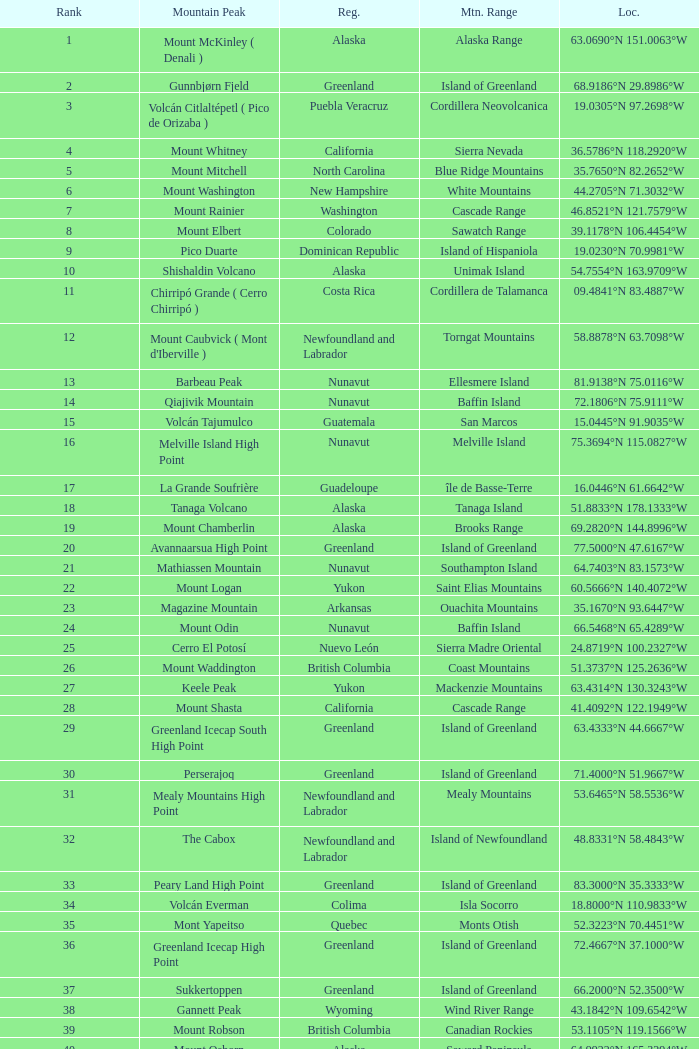Name the Mountain Peak which has a Rank of 62? Cerro Nube ( Quie Yelaag ). 